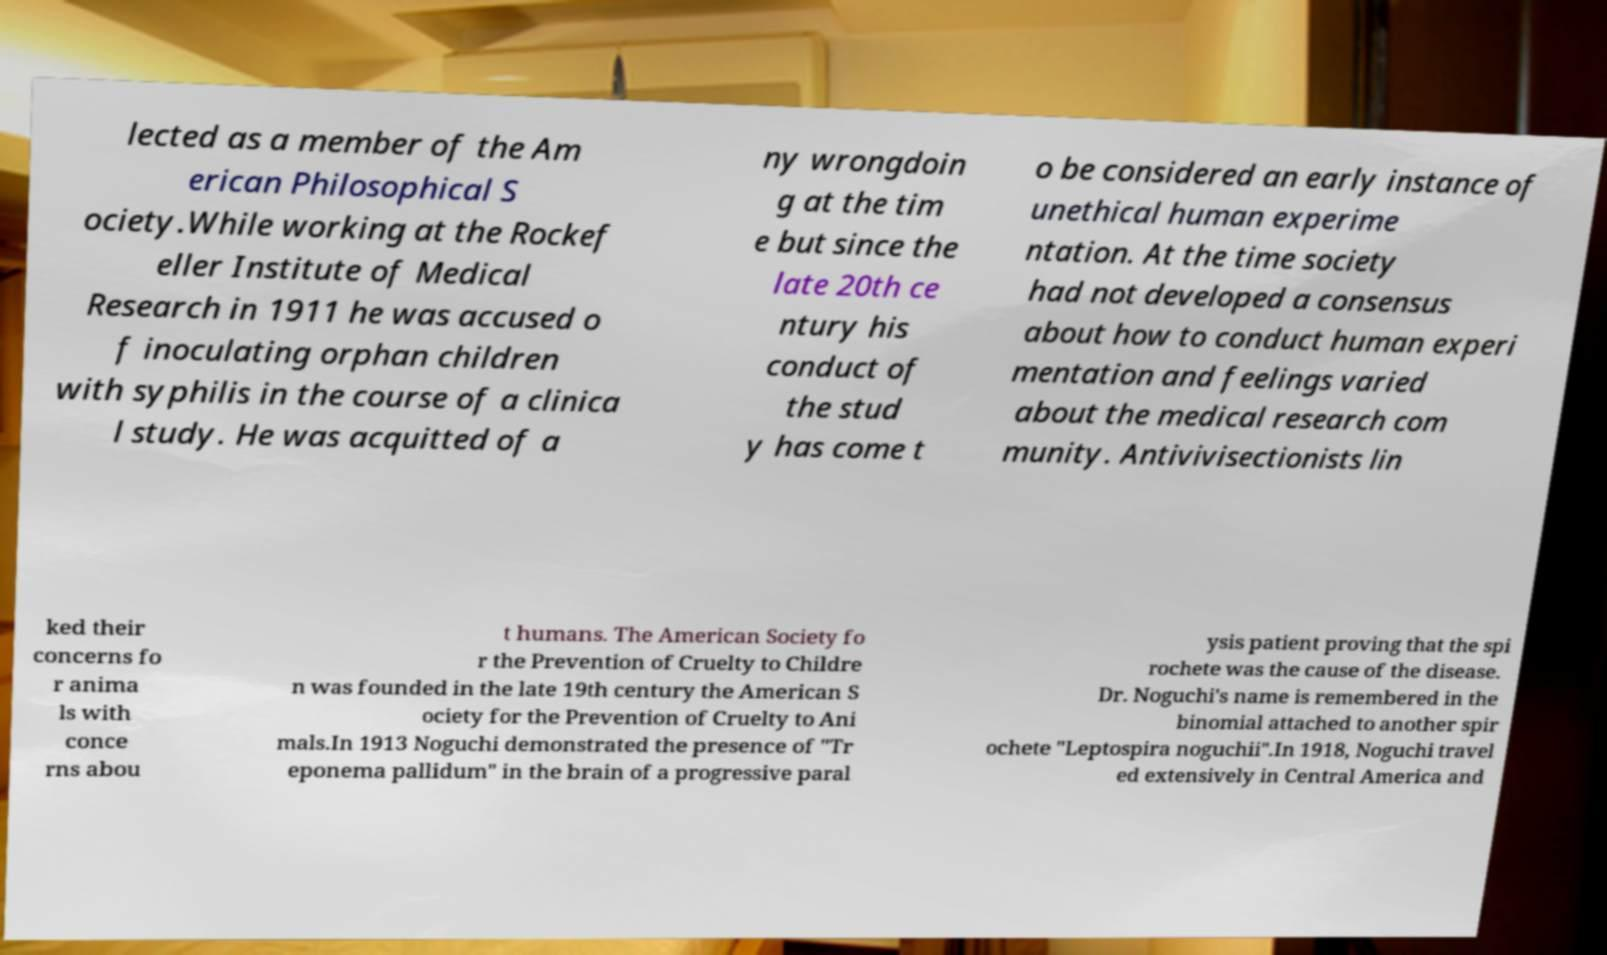Can you accurately transcribe the text from the provided image for me? lected as a member of the Am erican Philosophical S ociety.While working at the Rockef eller Institute of Medical Research in 1911 he was accused o f inoculating orphan children with syphilis in the course of a clinica l study. He was acquitted of a ny wrongdoin g at the tim e but since the late 20th ce ntury his conduct of the stud y has come t o be considered an early instance of unethical human experime ntation. At the time society had not developed a consensus about how to conduct human experi mentation and feelings varied about the medical research com munity. Antivivisectionists lin ked their concerns fo r anima ls with conce rns abou t humans. The American Society fo r the Prevention of Cruelty to Childre n was founded in the late 19th century the American S ociety for the Prevention of Cruelty to Ani mals.In 1913 Noguchi demonstrated the presence of "Tr eponema pallidum" in the brain of a progressive paral ysis patient proving that the spi rochete was the cause of the disease. Dr. Noguchi's name is remembered in the binomial attached to another spir ochete "Leptospira noguchii".In 1918, Noguchi travel ed extensively in Central America and 